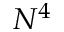Convert formula to latex. <formula><loc_0><loc_0><loc_500><loc_500>N ^ { 4 }</formula> 